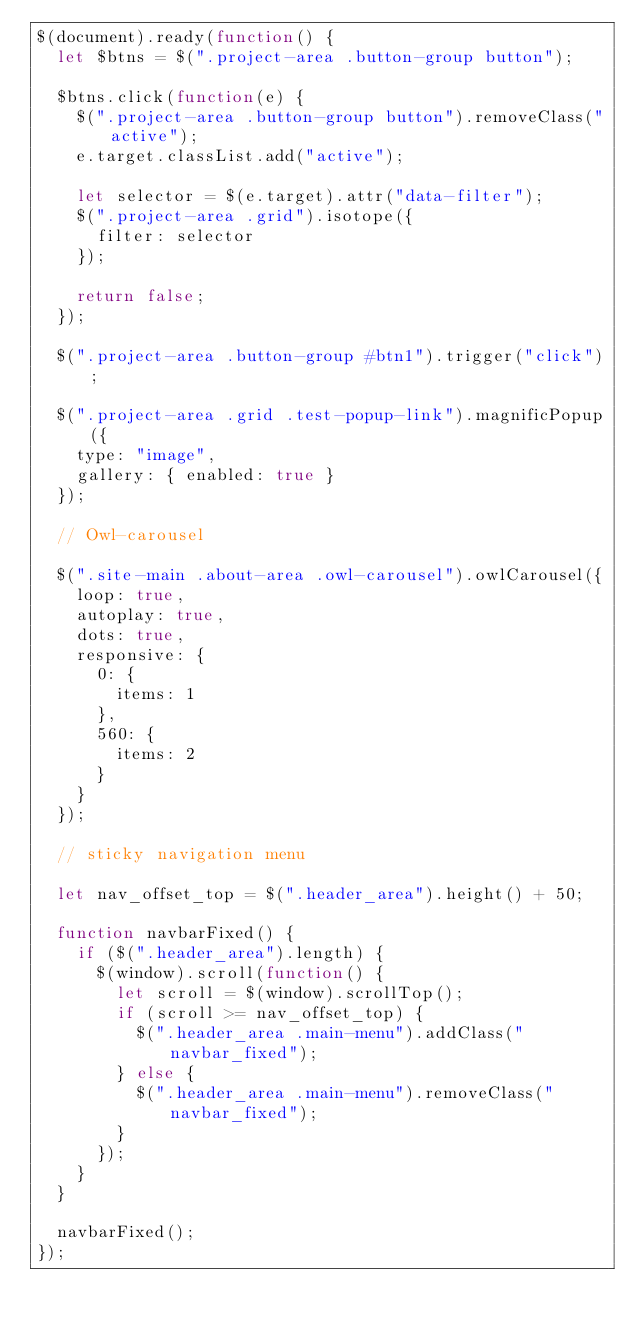Convert code to text. <code><loc_0><loc_0><loc_500><loc_500><_JavaScript_>$(document).ready(function() {
  let $btns = $(".project-area .button-group button");

  $btns.click(function(e) {
    $(".project-area .button-group button").removeClass("active");
    e.target.classList.add("active");

    let selector = $(e.target).attr("data-filter");
    $(".project-area .grid").isotope({
      filter: selector
    });

    return false;
  });

  $(".project-area .button-group #btn1").trigger("click");

  $(".project-area .grid .test-popup-link").magnificPopup({
    type: "image",
    gallery: { enabled: true }
  });

  // Owl-carousel

  $(".site-main .about-area .owl-carousel").owlCarousel({
    loop: true,
    autoplay: true,
    dots: true,
    responsive: {
      0: {
        items: 1
      },
      560: {
        items: 2
      }
    }
  });

  // sticky navigation menu

  let nav_offset_top = $(".header_area").height() + 50;

  function navbarFixed() {
    if ($(".header_area").length) {
      $(window).scroll(function() {
        let scroll = $(window).scrollTop();
        if (scroll >= nav_offset_top) {
          $(".header_area .main-menu").addClass("navbar_fixed");
        } else {
          $(".header_area .main-menu").removeClass("navbar_fixed");
        }
      });
    }
  }

  navbarFixed();
});
</code> 